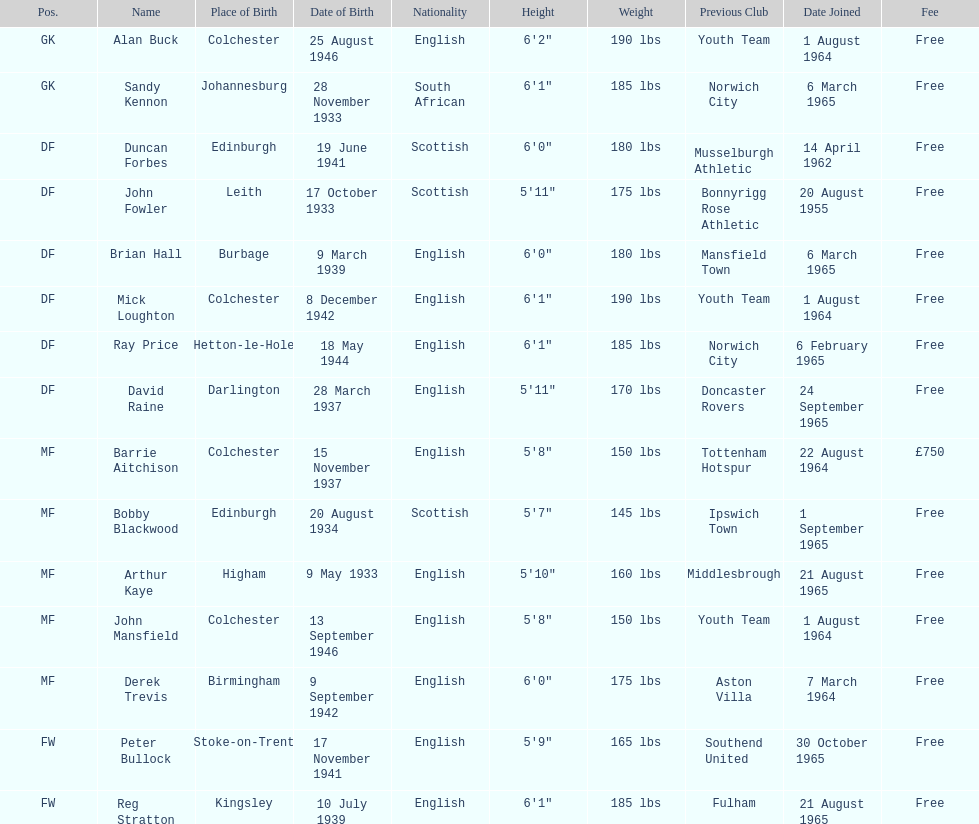What is the date of the lst player that joined? 20 August 1955. 